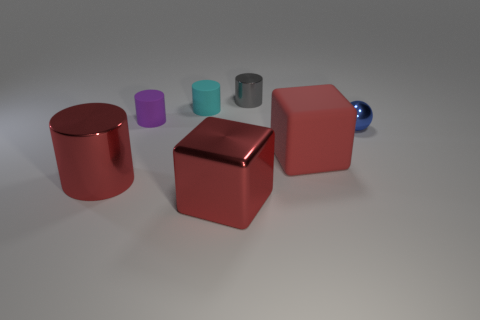Is the rubber block the same color as the large shiny cylinder?
Offer a very short reply. Yes. There is a tiny thing that is made of the same material as the gray cylinder; what is its shape?
Give a very brief answer. Sphere. Is there any other thing of the same color as the rubber block?
Ensure brevity in your answer.  Yes. What material is the big red thing that is the same shape as the purple matte object?
Keep it short and to the point. Metal. What number of other things are there of the same size as the blue thing?
Keep it short and to the point. 3. What material is the tiny purple cylinder?
Your response must be concise. Rubber. Are there more small metal things behind the small blue shiny sphere than big rubber cylinders?
Provide a short and direct response. Yes. Is there a small green cylinder?
Your answer should be very brief. No. What number of other objects are the same shape as the blue object?
Your answer should be very brief. 0. There is a rubber thing that is in front of the purple cylinder; is it the same color as the object in front of the large shiny cylinder?
Provide a succinct answer. Yes. 